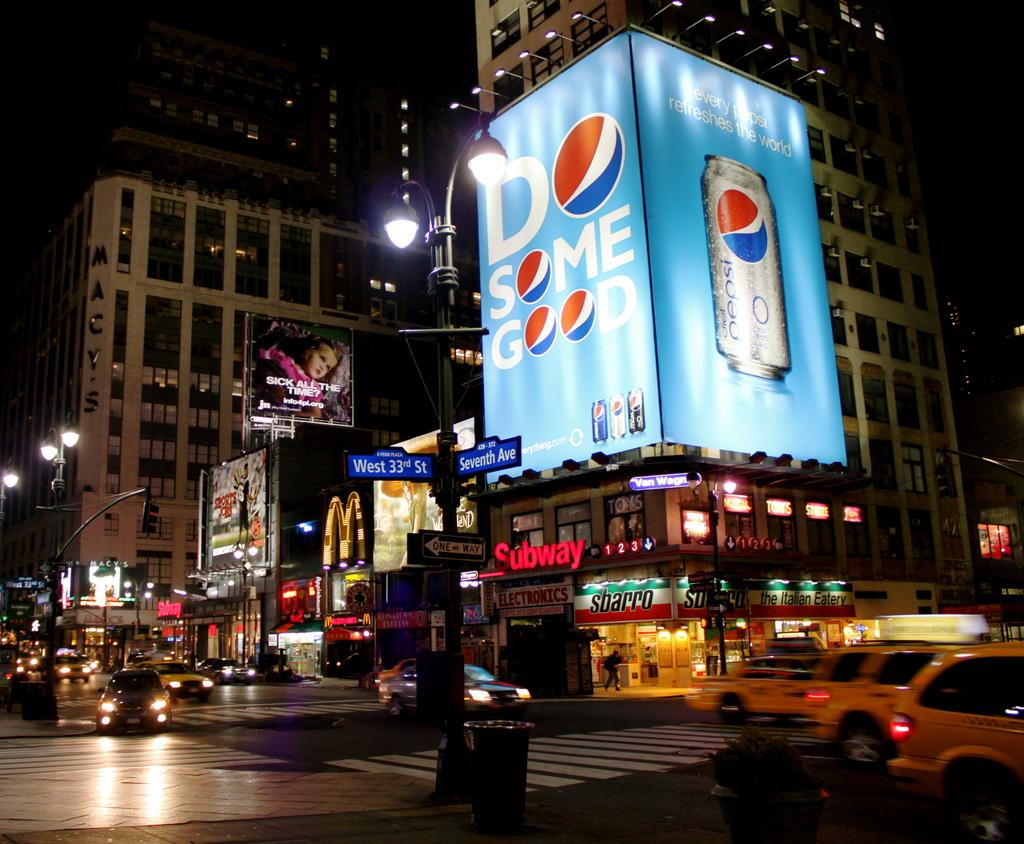Provide a one-sentence caption for the provided image. a Pepsi logo that is on a building. 